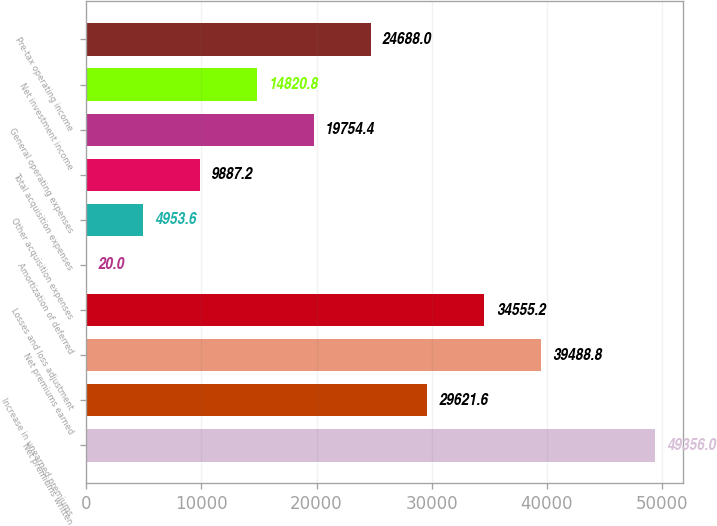Convert chart. <chart><loc_0><loc_0><loc_500><loc_500><bar_chart><fcel>Net premiums written<fcel>Increase in unearned premiums<fcel>Net premiums earned<fcel>Losses and loss adjustment<fcel>Amortization of deferred<fcel>Other acquisition expenses<fcel>Total acquisition expenses<fcel>General operating expenses<fcel>Net investment income<fcel>Pre-tax operating income<nl><fcel>49356<fcel>29621.6<fcel>39488.8<fcel>34555.2<fcel>20<fcel>4953.6<fcel>9887.2<fcel>19754.4<fcel>14820.8<fcel>24688<nl></chart> 